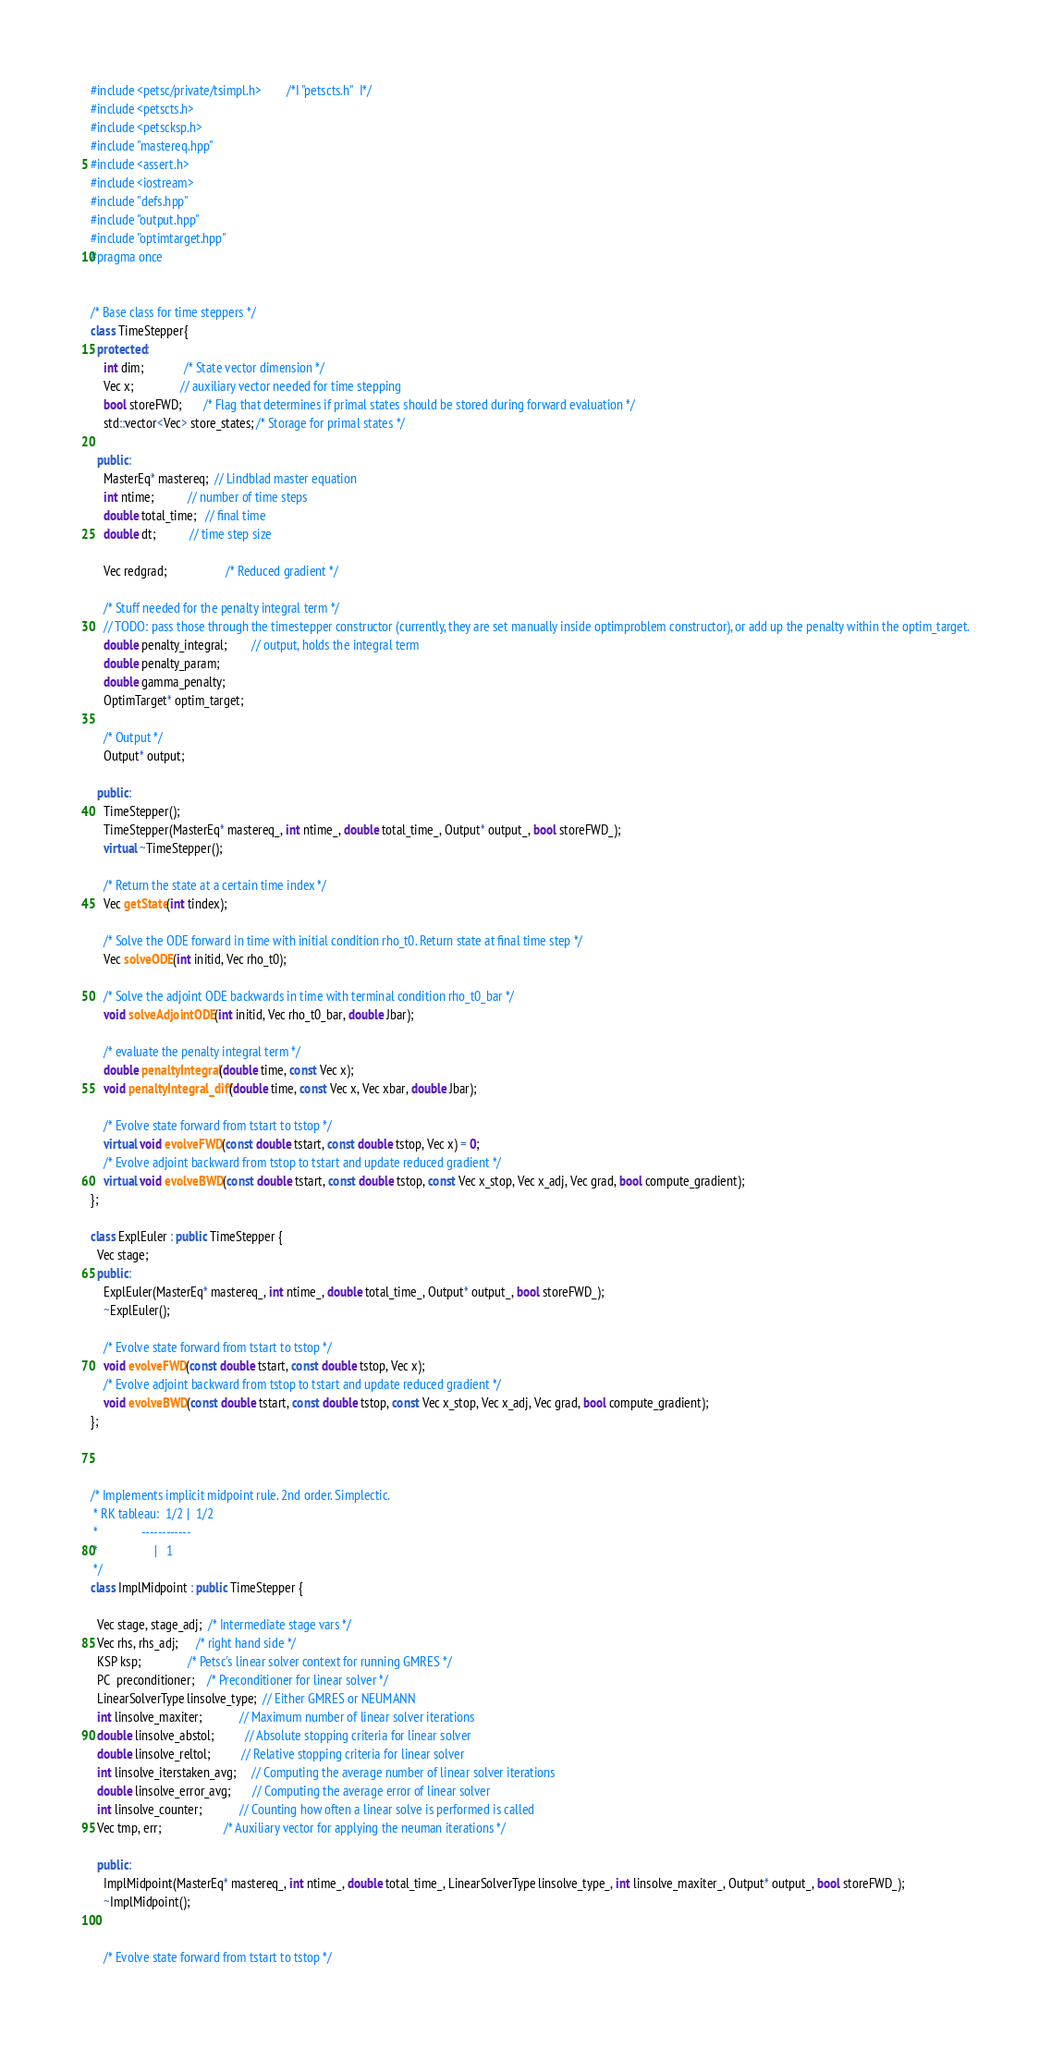<code> <loc_0><loc_0><loc_500><loc_500><_C++_>#include <petsc/private/tsimpl.h>        /*I "petscts.h"  I*/
#include <petscts.h>
#include <petscksp.h>
#include "mastereq.hpp"
#include <assert.h> 
#include <iostream> 
#include "defs.hpp"
#include "output.hpp"
#include "optimtarget.hpp"
#pragma once


/* Base class for time steppers */
class TimeStepper{
  protected:
    int dim;             /* State vector dimension */
    Vec x;               // auxiliary vector needed for time stepping
    bool storeFWD;       /* Flag that determines if primal states should be stored during forward evaluation */
    std::vector<Vec> store_states; /* Storage for primal states */

  public:
    MasterEq* mastereq;  // Lindblad master equation
    int ntime;           // number of time steps
    double total_time;   // final time
    double dt;           // time step size

    Vec redgrad;                   /* Reduced gradient */

    /* Stuff needed for the penalty integral term */
    // TODO: pass those through the timestepper constructor (currently, they are set manually inside optimproblem constructor), or add up the penalty within the optim_target.
    double penalty_integral;        // output, holds the integral term
    double penalty_param;
    double gamma_penalty;
    OptimTarget* optim_target;

    /* Output */
    Output* output;

  public: 
    TimeStepper(); 
    TimeStepper(MasterEq* mastereq_, int ntime_, double total_time_, Output* output_, bool storeFWD_); 
    virtual ~TimeStepper(); 

    /* Return the state at a certain time index */
    Vec getState(int tindex);

    /* Solve the ODE forward in time with initial condition rho_t0. Return state at final time step */
    Vec solveODE(int initid, Vec rho_t0);

    /* Solve the adjoint ODE backwards in time with terminal condition rho_t0_bar */
    void solveAdjointODE(int initid, Vec rho_t0_bar, double Jbar);

    /* evaluate the penalty integral term */
    double penaltyIntegral(double time, const Vec x);
    void penaltyIntegral_diff(double time, const Vec x, Vec xbar, double Jbar);

    /* Evolve state forward from tstart to tstop */
    virtual void evolveFWD(const double tstart, const double tstop, Vec x) = 0;
    /* Evolve adjoint backward from tstop to tstart and update reduced gradient */
    virtual void evolveBWD(const double tstart, const double tstop, const Vec x_stop, Vec x_adj, Vec grad, bool compute_gradient);
};

class ExplEuler : public TimeStepper {
  Vec stage;
  public:
    ExplEuler(MasterEq* mastereq_, int ntime_, double total_time_, Output* output_, bool storeFWD_);
    ~ExplEuler();

    /* Evolve state forward from tstart to tstop */
    void evolveFWD(const double tstart, const double tstop, Vec x);
    /* Evolve adjoint backward from tstop to tstart and update reduced gradient */
    void evolveBWD(const double tstart, const double tstop, const Vec x_stop, Vec x_adj, Vec grad, bool compute_gradient);
};



/* Implements implicit midpoint rule. 2nd order. Simplectic. 
 * RK tableau:  1/2 |  1/2
 *              ------------
 *                  |   1
 */
class ImplMidpoint : public TimeStepper {

  Vec stage, stage_adj;  /* Intermediate stage vars */
  Vec rhs, rhs_adj;      /* right hand side */
  KSP ksp;               /* Petsc's linear solver context for running GMRES */
  PC  preconditioner;    /* Preconditioner for linear solver */
  LinearSolverType linsolve_type;  // Either GMRES or NEUMANN
  int linsolve_maxiter;            // Maximum number of linear solver iterations
  double linsolve_abstol;          // Absolute stopping criteria for linear solver
  double linsolve_reltol;          // Relative stopping criteria for linear solver
  int linsolve_iterstaken_avg;     // Computing the average number of linear solver iterations
  double linsolve_error_avg;       // Computing the average error of linear solver 
  int linsolve_counter;            // Counting how often a linear solve is performed is called
  Vec tmp, err;                    /* Auxiliary vector for applying the neuman iterations */

  public:
    ImplMidpoint(MasterEq* mastereq_, int ntime_, double total_time_, LinearSolverType linsolve_type_, int linsolve_maxiter_, Output* output_, bool storeFWD_);
    ~ImplMidpoint();


    /* Evolve state forward from tstart to tstop */</code> 